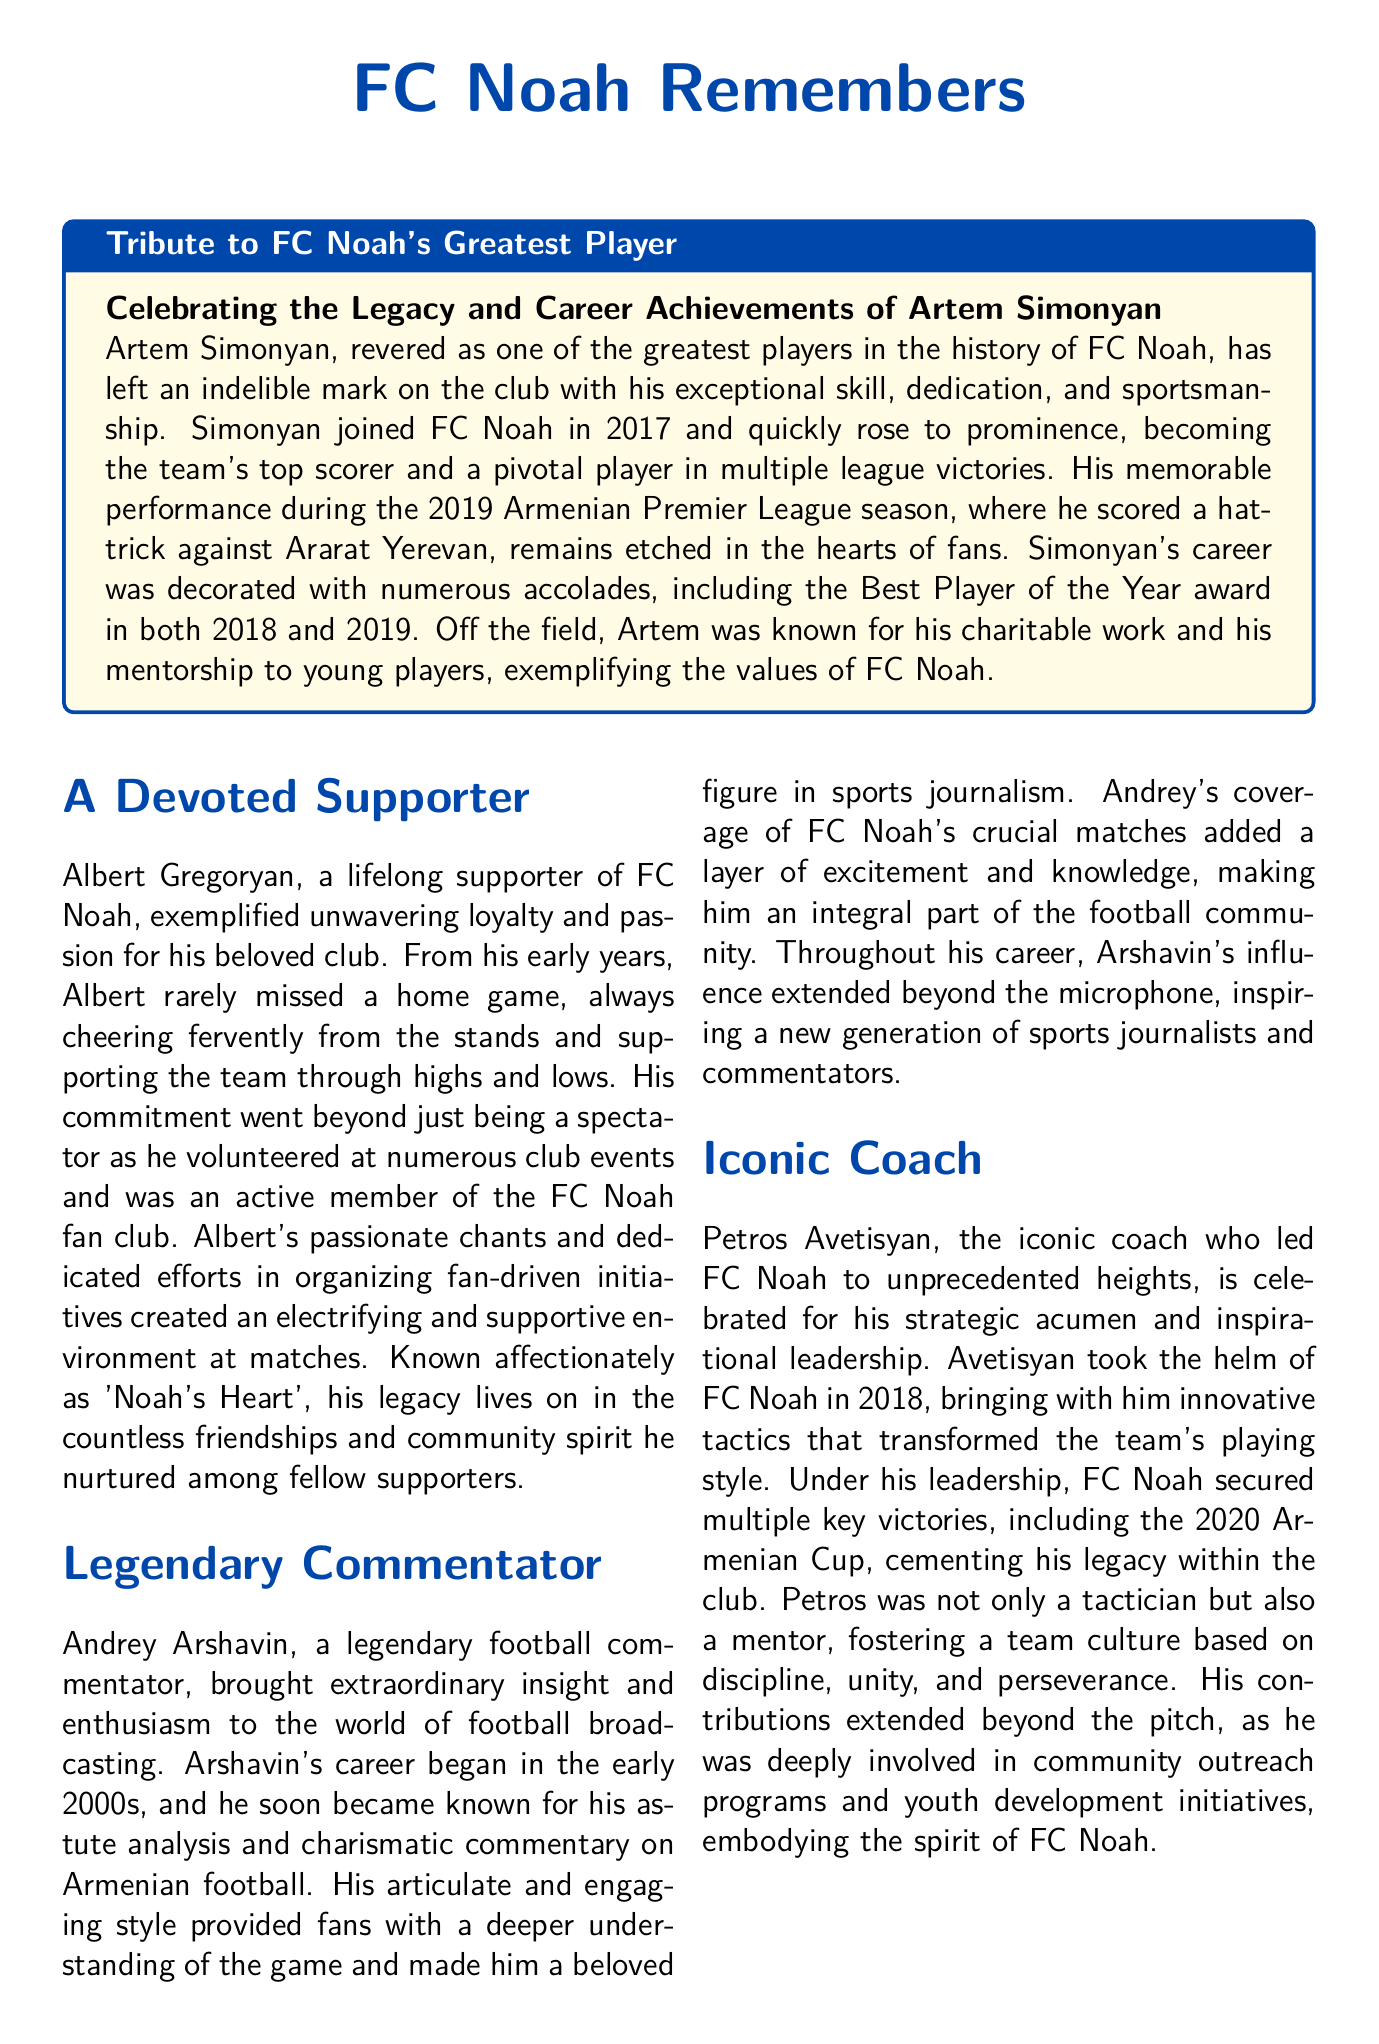What is the full name of FC Noah's greatest player? The document names Artem Simonyan as FC Noah's greatest player.
Answer: Artem Simonyan In which year did Artem Simonyan join FC Noah? The document states that Artem Simonyan joined FC Noah in 2017.
Answer: 2017 How many times did Artem Simonyan win the Best Player of the Year award? The document mentions that Simonyan won the Best Player of the Year award in both 2018 and 2019, totaling two awards.
Answer: 2 Who is referred to as "Noah's Heart"? The document describes Albert Gregoryan as affectionately known as "Noah's Heart."
Answer: Albert Gregoryan What significant tournament did Petros Avetisyan lead FC Noah to win? The document notes that Petros Avetisyan led FC Noah to win the 2020 Armenian Cup.
Answer: 2020 Armenian Cup What role did Andrey Arshavin have in the football community? The document indicates that Andrey Arshavin was a legendary football commentator.
Answer: Commentator How long did Martin Hayrapetyan's journalism career span? The document states that Martin Hayrapetyan's career spanned over two decades.
Answer: Over two decades What type of work was Artem Simonyan known for off the field? The document highlights Simonyan's charitable work and mentorship to young players off the field.
Answer: Charitable work What year did Petros Avetisyan become the head coach of FC Noah? The document mentions that Avetisyan took the helm of FC Noah in 2018.
Answer: 2018 